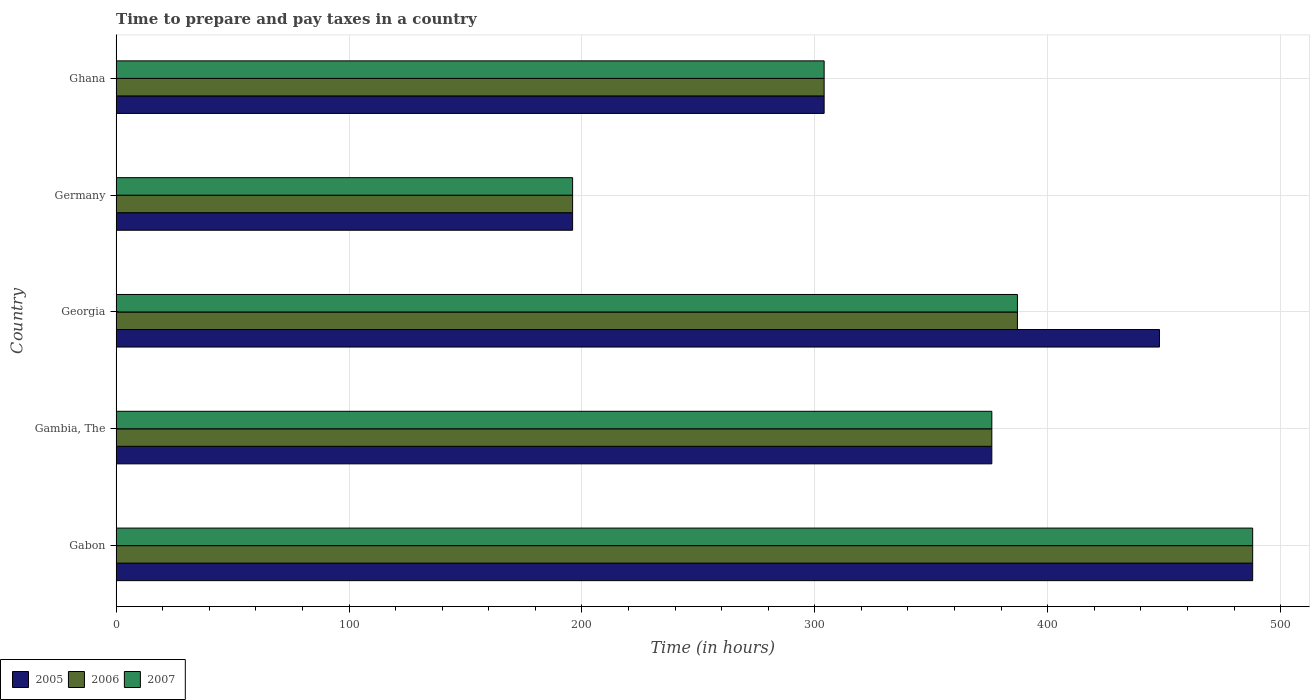Are the number of bars on each tick of the Y-axis equal?
Give a very brief answer. Yes. How many bars are there on the 1st tick from the bottom?
Your answer should be very brief. 3. What is the label of the 5th group of bars from the top?
Your answer should be compact. Gabon. What is the number of hours required to prepare and pay taxes in 2005 in Ghana?
Offer a very short reply. 304. Across all countries, what is the maximum number of hours required to prepare and pay taxes in 2005?
Your answer should be compact. 488. Across all countries, what is the minimum number of hours required to prepare and pay taxes in 2006?
Give a very brief answer. 196. In which country was the number of hours required to prepare and pay taxes in 2006 maximum?
Offer a terse response. Gabon. What is the total number of hours required to prepare and pay taxes in 2006 in the graph?
Make the answer very short. 1751. What is the difference between the number of hours required to prepare and pay taxes in 2007 in Germany and that in Ghana?
Offer a very short reply. -108. What is the difference between the number of hours required to prepare and pay taxes in 2007 in Germany and the number of hours required to prepare and pay taxes in 2006 in Gabon?
Provide a short and direct response. -292. What is the average number of hours required to prepare and pay taxes in 2005 per country?
Make the answer very short. 362.4. What is the difference between the number of hours required to prepare and pay taxes in 2006 and number of hours required to prepare and pay taxes in 2007 in Ghana?
Ensure brevity in your answer.  0. In how many countries, is the number of hours required to prepare and pay taxes in 2006 greater than 280 hours?
Make the answer very short. 4. What is the ratio of the number of hours required to prepare and pay taxes in 2005 in Gabon to that in Georgia?
Keep it short and to the point. 1.09. Is the number of hours required to prepare and pay taxes in 2007 in Gambia, The less than that in Georgia?
Make the answer very short. Yes. Is the difference between the number of hours required to prepare and pay taxes in 2006 in Germany and Ghana greater than the difference between the number of hours required to prepare and pay taxes in 2007 in Germany and Ghana?
Offer a very short reply. No. What is the difference between the highest and the second highest number of hours required to prepare and pay taxes in 2005?
Your answer should be very brief. 40. What is the difference between the highest and the lowest number of hours required to prepare and pay taxes in 2007?
Offer a very short reply. 292. Is the sum of the number of hours required to prepare and pay taxes in 2005 in Georgia and Germany greater than the maximum number of hours required to prepare and pay taxes in 2007 across all countries?
Offer a very short reply. Yes. What does the 3rd bar from the top in Gambia, The represents?
Make the answer very short. 2005. What does the 3rd bar from the bottom in Ghana represents?
Keep it short and to the point. 2007. Is it the case that in every country, the sum of the number of hours required to prepare and pay taxes in 2006 and number of hours required to prepare and pay taxes in 2005 is greater than the number of hours required to prepare and pay taxes in 2007?
Make the answer very short. Yes. What is the difference between two consecutive major ticks on the X-axis?
Your answer should be compact. 100. Are the values on the major ticks of X-axis written in scientific E-notation?
Give a very brief answer. No. Where does the legend appear in the graph?
Your answer should be compact. Bottom left. How many legend labels are there?
Provide a short and direct response. 3. How are the legend labels stacked?
Your response must be concise. Horizontal. What is the title of the graph?
Offer a very short reply. Time to prepare and pay taxes in a country. Does "1972" appear as one of the legend labels in the graph?
Your response must be concise. No. What is the label or title of the X-axis?
Provide a succinct answer. Time (in hours). What is the Time (in hours) in 2005 in Gabon?
Make the answer very short. 488. What is the Time (in hours) in 2006 in Gabon?
Make the answer very short. 488. What is the Time (in hours) of 2007 in Gabon?
Provide a short and direct response. 488. What is the Time (in hours) of 2005 in Gambia, The?
Your answer should be compact. 376. What is the Time (in hours) in 2006 in Gambia, The?
Make the answer very short. 376. What is the Time (in hours) in 2007 in Gambia, The?
Ensure brevity in your answer.  376. What is the Time (in hours) of 2005 in Georgia?
Provide a succinct answer. 448. What is the Time (in hours) in 2006 in Georgia?
Your answer should be compact. 387. What is the Time (in hours) in 2007 in Georgia?
Your response must be concise. 387. What is the Time (in hours) in 2005 in Germany?
Your answer should be very brief. 196. What is the Time (in hours) in 2006 in Germany?
Make the answer very short. 196. What is the Time (in hours) in 2007 in Germany?
Your answer should be compact. 196. What is the Time (in hours) of 2005 in Ghana?
Your response must be concise. 304. What is the Time (in hours) in 2006 in Ghana?
Offer a terse response. 304. What is the Time (in hours) in 2007 in Ghana?
Keep it short and to the point. 304. Across all countries, what is the maximum Time (in hours) of 2005?
Provide a short and direct response. 488. Across all countries, what is the maximum Time (in hours) of 2006?
Your answer should be very brief. 488. Across all countries, what is the maximum Time (in hours) of 2007?
Your answer should be compact. 488. Across all countries, what is the minimum Time (in hours) of 2005?
Offer a very short reply. 196. Across all countries, what is the minimum Time (in hours) in 2006?
Offer a very short reply. 196. Across all countries, what is the minimum Time (in hours) of 2007?
Your answer should be compact. 196. What is the total Time (in hours) of 2005 in the graph?
Offer a terse response. 1812. What is the total Time (in hours) in 2006 in the graph?
Offer a very short reply. 1751. What is the total Time (in hours) in 2007 in the graph?
Offer a very short reply. 1751. What is the difference between the Time (in hours) of 2005 in Gabon and that in Gambia, The?
Give a very brief answer. 112. What is the difference between the Time (in hours) of 2006 in Gabon and that in Gambia, The?
Ensure brevity in your answer.  112. What is the difference between the Time (in hours) of 2007 in Gabon and that in Gambia, The?
Provide a succinct answer. 112. What is the difference between the Time (in hours) of 2006 in Gabon and that in Georgia?
Give a very brief answer. 101. What is the difference between the Time (in hours) of 2007 in Gabon and that in Georgia?
Keep it short and to the point. 101. What is the difference between the Time (in hours) of 2005 in Gabon and that in Germany?
Your response must be concise. 292. What is the difference between the Time (in hours) of 2006 in Gabon and that in Germany?
Offer a terse response. 292. What is the difference between the Time (in hours) of 2007 in Gabon and that in Germany?
Make the answer very short. 292. What is the difference between the Time (in hours) in 2005 in Gabon and that in Ghana?
Provide a succinct answer. 184. What is the difference between the Time (in hours) in 2006 in Gabon and that in Ghana?
Offer a terse response. 184. What is the difference between the Time (in hours) of 2007 in Gabon and that in Ghana?
Provide a short and direct response. 184. What is the difference between the Time (in hours) of 2005 in Gambia, The and that in Georgia?
Your answer should be very brief. -72. What is the difference between the Time (in hours) in 2007 in Gambia, The and that in Georgia?
Provide a succinct answer. -11. What is the difference between the Time (in hours) in 2005 in Gambia, The and that in Germany?
Offer a very short reply. 180. What is the difference between the Time (in hours) of 2006 in Gambia, The and that in Germany?
Offer a terse response. 180. What is the difference between the Time (in hours) of 2007 in Gambia, The and that in Germany?
Offer a terse response. 180. What is the difference between the Time (in hours) of 2006 in Gambia, The and that in Ghana?
Make the answer very short. 72. What is the difference between the Time (in hours) in 2007 in Gambia, The and that in Ghana?
Your answer should be very brief. 72. What is the difference between the Time (in hours) in 2005 in Georgia and that in Germany?
Offer a very short reply. 252. What is the difference between the Time (in hours) in 2006 in Georgia and that in Germany?
Give a very brief answer. 191. What is the difference between the Time (in hours) in 2007 in Georgia and that in Germany?
Offer a terse response. 191. What is the difference between the Time (in hours) in 2005 in Georgia and that in Ghana?
Provide a short and direct response. 144. What is the difference between the Time (in hours) in 2006 in Georgia and that in Ghana?
Provide a short and direct response. 83. What is the difference between the Time (in hours) of 2005 in Germany and that in Ghana?
Offer a terse response. -108. What is the difference between the Time (in hours) in 2006 in Germany and that in Ghana?
Your response must be concise. -108. What is the difference between the Time (in hours) of 2007 in Germany and that in Ghana?
Provide a short and direct response. -108. What is the difference between the Time (in hours) in 2005 in Gabon and the Time (in hours) in 2006 in Gambia, The?
Make the answer very short. 112. What is the difference between the Time (in hours) in 2005 in Gabon and the Time (in hours) in 2007 in Gambia, The?
Provide a succinct answer. 112. What is the difference between the Time (in hours) of 2006 in Gabon and the Time (in hours) of 2007 in Gambia, The?
Give a very brief answer. 112. What is the difference between the Time (in hours) in 2005 in Gabon and the Time (in hours) in 2006 in Georgia?
Your answer should be compact. 101. What is the difference between the Time (in hours) of 2005 in Gabon and the Time (in hours) of 2007 in Georgia?
Your response must be concise. 101. What is the difference between the Time (in hours) in 2006 in Gabon and the Time (in hours) in 2007 in Georgia?
Give a very brief answer. 101. What is the difference between the Time (in hours) of 2005 in Gabon and the Time (in hours) of 2006 in Germany?
Your answer should be compact. 292. What is the difference between the Time (in hours) in 2005 in Gabon and the Time (in hours) in 2007 in Germany?
Provide a short and direct response. 292. What is the difference between the Time (in hours) of 2006 in Gabon and the Time (in hours) of 2007 in Germany?
Offer a very short reply. 292. What is the difference between the Time (in hours) in 2005 in Gabon and the Time (in hours) in 2006 in Ghana?
Your response must be concise. 184. What is the difference between the Time (in hours) of 2005 in Gabon and the Time (in hours) of 2007 in Ghana?
Give a very brief answer. 184. What is the difference between the Time (in hours) of 2006 in Gabon and the Time (in hours) of 2007 in Ghana?
Give a very brief answer. 184. What is the difference between the Time (in hours) in 2005 in Gambia, The and the Time (in hours) in 2007 in Georgia?
Your answer should be very brief. -11. What is the difference between the Time (in hours) in 2006 in Gambia, The and the Time (in hours) in 2007 in Georgia?
Provide a short and direct response. -11. What is the difference between the Time (in hours) in 2005 in Gambia, The and the Time (in hours) in 2006 in Germany?
Your answer should be compact. 180. What is the difference between the Time (in hours) in 2005 in Gambia, The and the Time (in hours) in 2007 in Germany?
Your response must be concise. 180. What is the difference between the Time (in hours) of 2006 in Gambia, The and the Time (in hours) of 2007 in Germany?
Provide a succinct answer. 180. What is the difference between the Time (in hours) in 2005 in Gambia, The and the Time (in hours) in 2007 in Ghana?
Provide a succinct answer. 72. What is the difference between the Time (in hours) in 2006 in Gambia, The and the Time (in hours) in 2007 in Ghana?
Provide a short and direct response. 72. What is the difference between the Time (in hours) of 2005 in Georgia and the Time (in hours) of 2006 in Germany?
Provide a short and direct response. 252. What is the difference between the Time (in hours) of 2005 in Georgia and the Time (in hours) of 2007 in Germany?
Offer a terse response. 252. What is the difference between the Time (in hours) in 2006 in Georgia and the Time (in hours) in 2007 in Germany?
Make the answer very short. 191. What is the difference between the Time (in hours) in 2005 in Georgia and the Time (in hours) in 2006 in Ghana?
Give a very brief answer. 144. What is the difference between the Time (in hours) in 2005 in Georgia and the Time (in hours) in 2007 in Ghana?
Keep it short and to the point. 144. What is the difference between the Time (in hours) in 2006 in Georgia and the Time (in hours) in 2007 in Ghana?
Your response must be concise. 83. What is the difference between the Time (in hours) of 2005 in Germany and the Time (in hours) of 2006 in Ghana?
Your answer should be very brief. -108. What is the difference between the Time (in hours) in 2005 in Germany and the Time (in hours) in 2007 in Ghana?
Offer a very short reply. -108. What is the difference between the Time (in hours) in 2006 in Germany and the Time (in hours) in 2007 in Ghana?
Ensure brevity in your answer.  -108. What is the average Time (in hours) of 2005 per country?
Offer a very short reply. 362.4. What is the average Time (in hours) of 2006 per country?
Offer a very short reply. 350.2. What is the average Time (in hours) in 2007 per country?
Make the answer very short. 350.2. What is the difference between the Time (in hours) of 2005 and Time (in hours) of 2007 in Gabon?
Provide a succinct answer. 0. What is the difference between the Time (in hours) of 2005 and Time (in hours) of 2006 in Gambia, The?
Ensure brevity in your answer.  0. What is the difference between the Time (in hours) in 2006 and Time (in hours) in 2007 in Gambia, The?
Your answer should be very brief. 0. What is the difference between the Time (in hours) in 2005 and Time (in hours) in 2006 in Georgia?
Your response must be concise. 61. What is the difference between the Time (in hours) in 2005 and Time (in hours) in 2007 in Georgia?
Offer a very short reply. 61. What is the difference between the Time (in hours) of 2005 and Time (in hours) of 2007 in Germany?
Your response must be concise. 0. What is the difference between the Time (in hours) of 2006 and Time (in hours) of 2007 in Ghana?
Ensure brevity in your answer.  0. What is the ratio of the Time (in hours) of 2005 in Gabon to that in Gambia, The?
Your answer should be compact. 1.3. What is the ratio of the Time (in hours) in 2006 in Gabon to that in Gambia, The?
Your answer should be very brief. 1.3. What is the ratio of the Time (in hours) of 2007 in Gabon to that in Gambia, The?
Provide a short and direct response. 1.3. What is the ratio of the Time (in hours) of 2005 in Gabon to that in Georgia?
Offer a terse response. 1.09. What is the ratio of the Time (in hours) in 2006 in Gabon to that in Georgia?
Keep it short and to the point. 1.26. What is the ratio of the Time (in hours) of 2007 in Gabon to that in Georgia?
Your answer should be very brief. 1.26. What is the ratio of the Time (in hours) of 2005 in Gabon to that in Germany?
Keep it short and to the point. 2.49. What is the ratio of the Time (in hours) of 2006 in Gabon to that in Germany?
Provide a succinct answer. 2.49. What is the ratio of the Time (in hours) of 2007 in Gabon to that in Germany?
Offer a terse response. 2.49. What is the ratio of the Time (in hours) in 2005 in Gabon to that in Ghana?
Make the answer very short. 1.61. What is the ratio of the Time (in hours) of 2006 in Gabon to that in Ghana?
Make the answer very short. 1.61. What is the ratio of the Time (in hours) in 2007 in Gabon to that in Ghana?
Make the answer very short. 1.61. What is the ratio of the Time (in hours) in 2005 in Gambia, The to that in Georgia?
Keep it short and to the point. 0.84. What is the ratio of the Time (in hours) in 2006 in Gambia, The to that in Georgia?
Ensure brevity in your answer.  0.97. What is the ratio of the Time (in hours) in 2007 in Gambia, The to that in Georgia?
Keep it short and to the point. 0.97. What is the ratio of the Time (in hours) of 2005 in Gambia, The to that in Germany?
Your answer should be very brief. 1.92. What is the ratio of the Time (in hours) of 2006 in Gambia, The to that in Germany?
Provide a short and direct response. 1.92. What is the ratio of the Time (in hours) in 2007 in Gambia, The to that in Germany?
Provide a short and direct response. 1.92. What is the ratio of the Time (in hours) in 2005 in Gambia, The to that in Ghana?
Provide a short and direct response. 1.24. What is the ratio of the Time (in hours) of 2006 in Gambia, The to that in Ghana?
Provide a succinct answer. 1.24. What is the ratio of the Time (in hours) in 2007 in Gambia, The to that in Ghana?
Keep it short and to the point. 1.24. What is the ratio of the Time (in hours) in 2005 in Georgia to that in Germany?
Ensure brevity in your answer.  2.29. What is the ratio of the Time (in hours) in 2006 in Georgia to that in Germany?
Ensure brevity in your answer.  1.97. What is the ratio of the Time (in hours) in 2007 in Georgia to that in Germany?
Provide a short and direct response. 1.97. What is the ratio of the Time (in hours) of 2005 in Georgia to that in Ghana?
Your response must be concise. 1.47. What is the ratio of the Time (in hours) of 2006 in Georgia to that in Ghana?
Your answer should be compact. 1.27. What is the ratio of the Time (in hours) in 2007 in Georgia to that in Ghana?
Offer a terse response. 1.27. What is the ratio of the Time (in hours) of 2005 in Germany to that in Ghana?
Provide a succinct answer. 0.64. What is the ratio of the Time (in hours) of 2006 in Germany to that in Ghana?
Provide a short and direct response. 0.64. What is the ratio of the Time (in hours) of 2007 in Germany to that in Ghana?
Ensure brevity in your answer.  0.64. What is the difference between the highest and the second highest Time (in hours) in 2006?
Your answer should be compact. 101. What is the difference between the highest and the second highest Time (in hours) in 2007?
Your response must be concise. 101. What is the difference between the highest and the lowest Time (in hours) of 2005?
Make the answer very short. 292. What is the difference between the highest and the lowest Time (in hours) of 2006?
Your response must be concise. 292. What is the difference between the highest and the lowest Time (in hours) of 2007?
Ensure brevity in your answer.  292. 